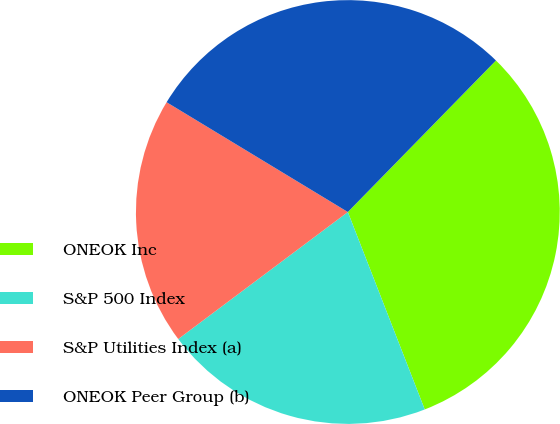<chart> <loc_0><loc_0><loc_500><loc_500><pie_chart><fcel>ONEOK Inc<fcel>S&P 500 Index<fcel>S&P Utilities Index (a)<fcel>ONEOK Peer Group (b)<nl><fcel>31.77%<fcel>20.68%<fcel>18.9%<fcel>28.65%<nl></chart> 